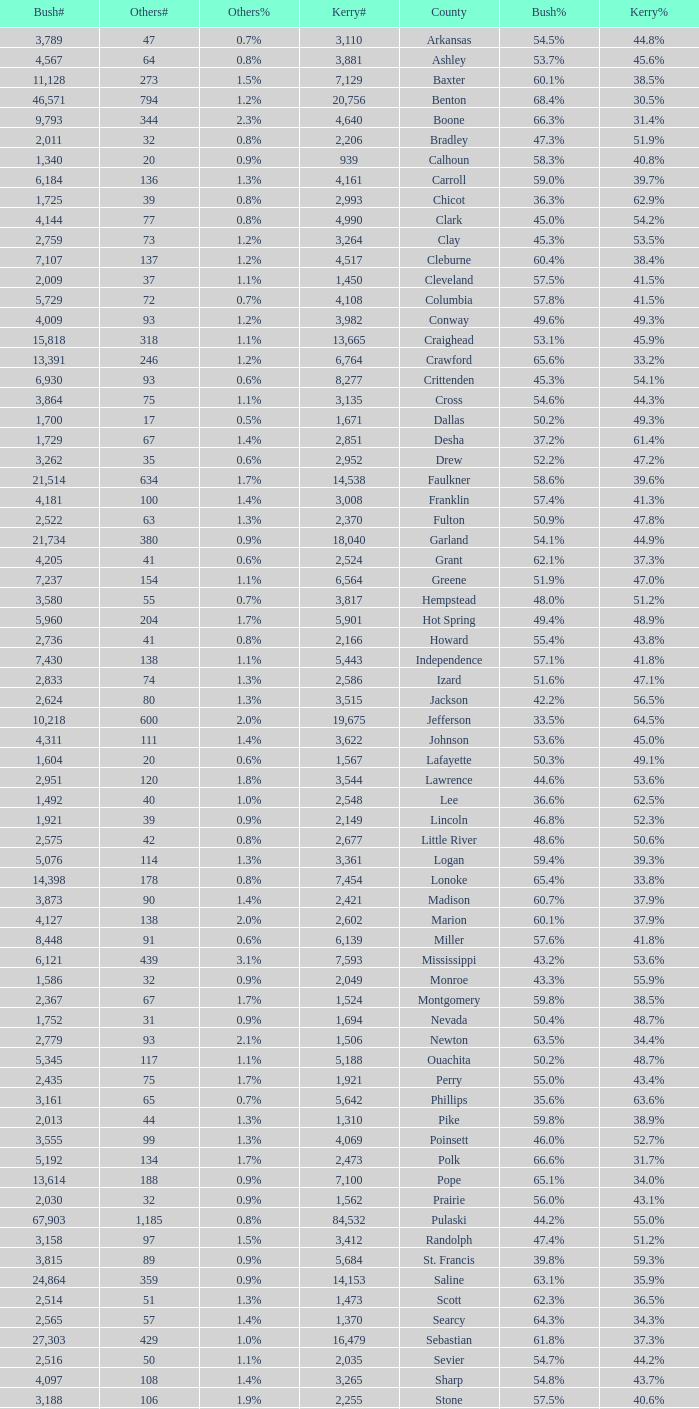What is the lowest Kerry#, when Others# is "106", and when Bush# is less than 3,188? None. 